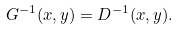<formula> <loc_0><loc_0><loc_500><loc_500>G ^ { - 1 } ( x , y ) = D ^ { - 1 } ( x , y ) .</formula> 